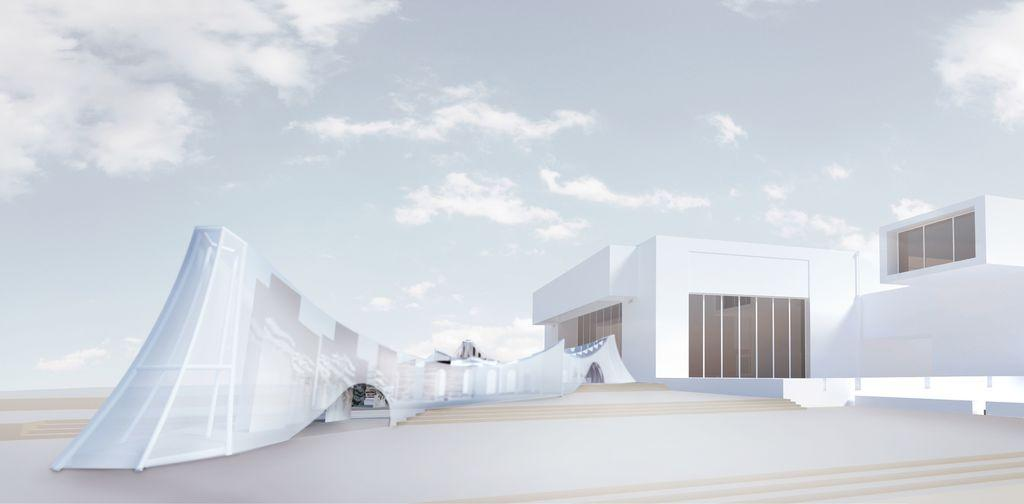What type of structure is present in the image? There is architecture and a building in the image. Can you describe the background of the image? The sky is visible in the background of the image. What type of payment method is accepted at the building in the image? There is no information about payment methods in the image, as it only features architecture and a building. 